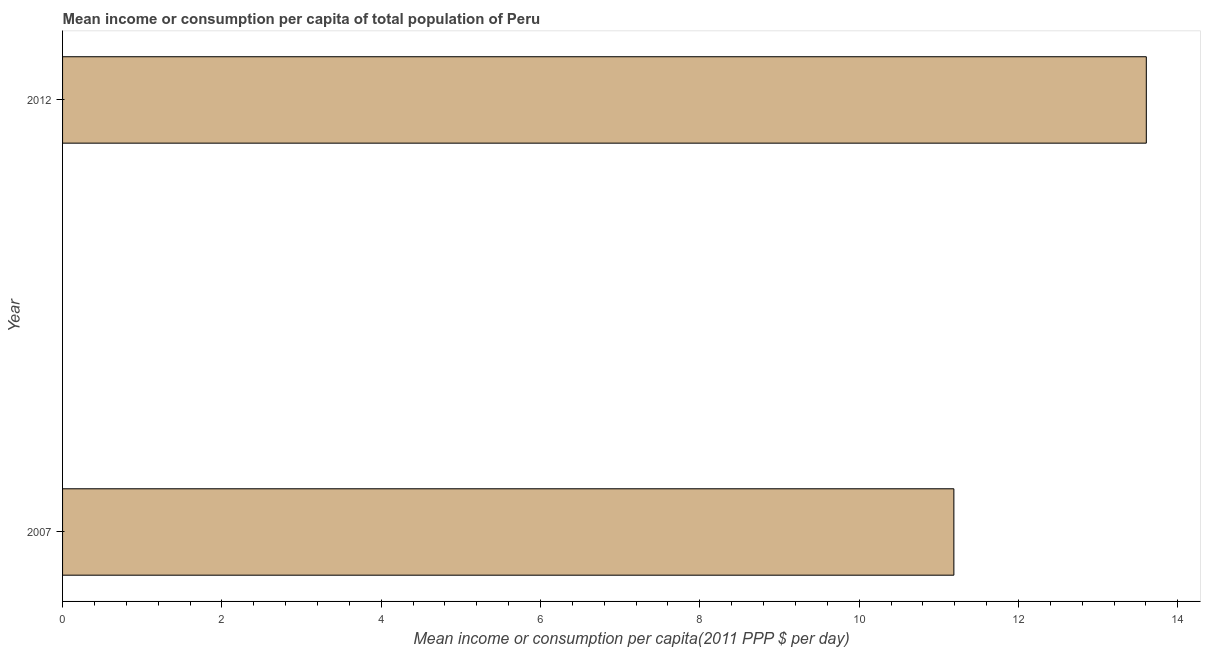Does the graph contain any zero values?
Give a very brief answer. No. What is the title of the graph?
Keep it short and to the point. Mean income or consumption per capita of total population of Peru. What is the label or title of the X-axis?
Offer a very short reply. Mean income or consumption per capita(2011 PPP $ per day). What is the label or title of the Y-axis?
Offer a very short reply. Year. What is the mean income or consumption in 2012?
Your answer should be compact. 13.61. Across all years, what is the maximum mean income or consumption?
Provide a short and direct response. 13.61. Across all years, what is the minimum mean income or consumption?
Offer a very short reply. 11.19. In which year was the mean income or consumption maximum?
Offer a terse response. 2012. What is the sum of the mean income or consumption?
Your answer should be compact. 24.79. What is the difference between the mean income or consumption in 2007 and 2012?
Your answer should be very brief. -2.42. What is the average mean income or consumption per year?
Make the answer very short. 12.4. What is the median mean income or consumption?
Keep it short and to the point. 12.4. In how many years, is the mean income or consumption greater than 0.8 $?
Your response must be concise. 2. What is the ratio of the mean income or consumption in 2007 to that in 2012?
Offer a very short reply. 0.82. Is the mean income or consumption in 2007 less than that in 2012?
Provide a succinct answer. Yes. Are all the bars in the graph horizontal?
Offer a very short reply. Yes. What is the difference between two consecutive major ticks on the X-axis?
Your answer should be very brief. 2. Are the values on the major ticks of X-axis written in scientific E-notation?
Your answer should be compact. No. What is the Mean income or consumption per capita(2011 PPP $ per day) in 2007?
Provide a succinct answer. 11.19. What is the Mean income or consumption per capita(2011 PPP $ per day) in 2012?
Offer a terse response. 13.61. What is the difference between the Mean income or consumption per capita(2011 PPP $ per day) in 2007 and 2012?
Keep it short and to the point. -2.42. What is the ratio of the Mean income or consumption per capita(2011 PPP $ per day) in 2007 to that in 2012?
Your answer should be very brief. 0.82. 